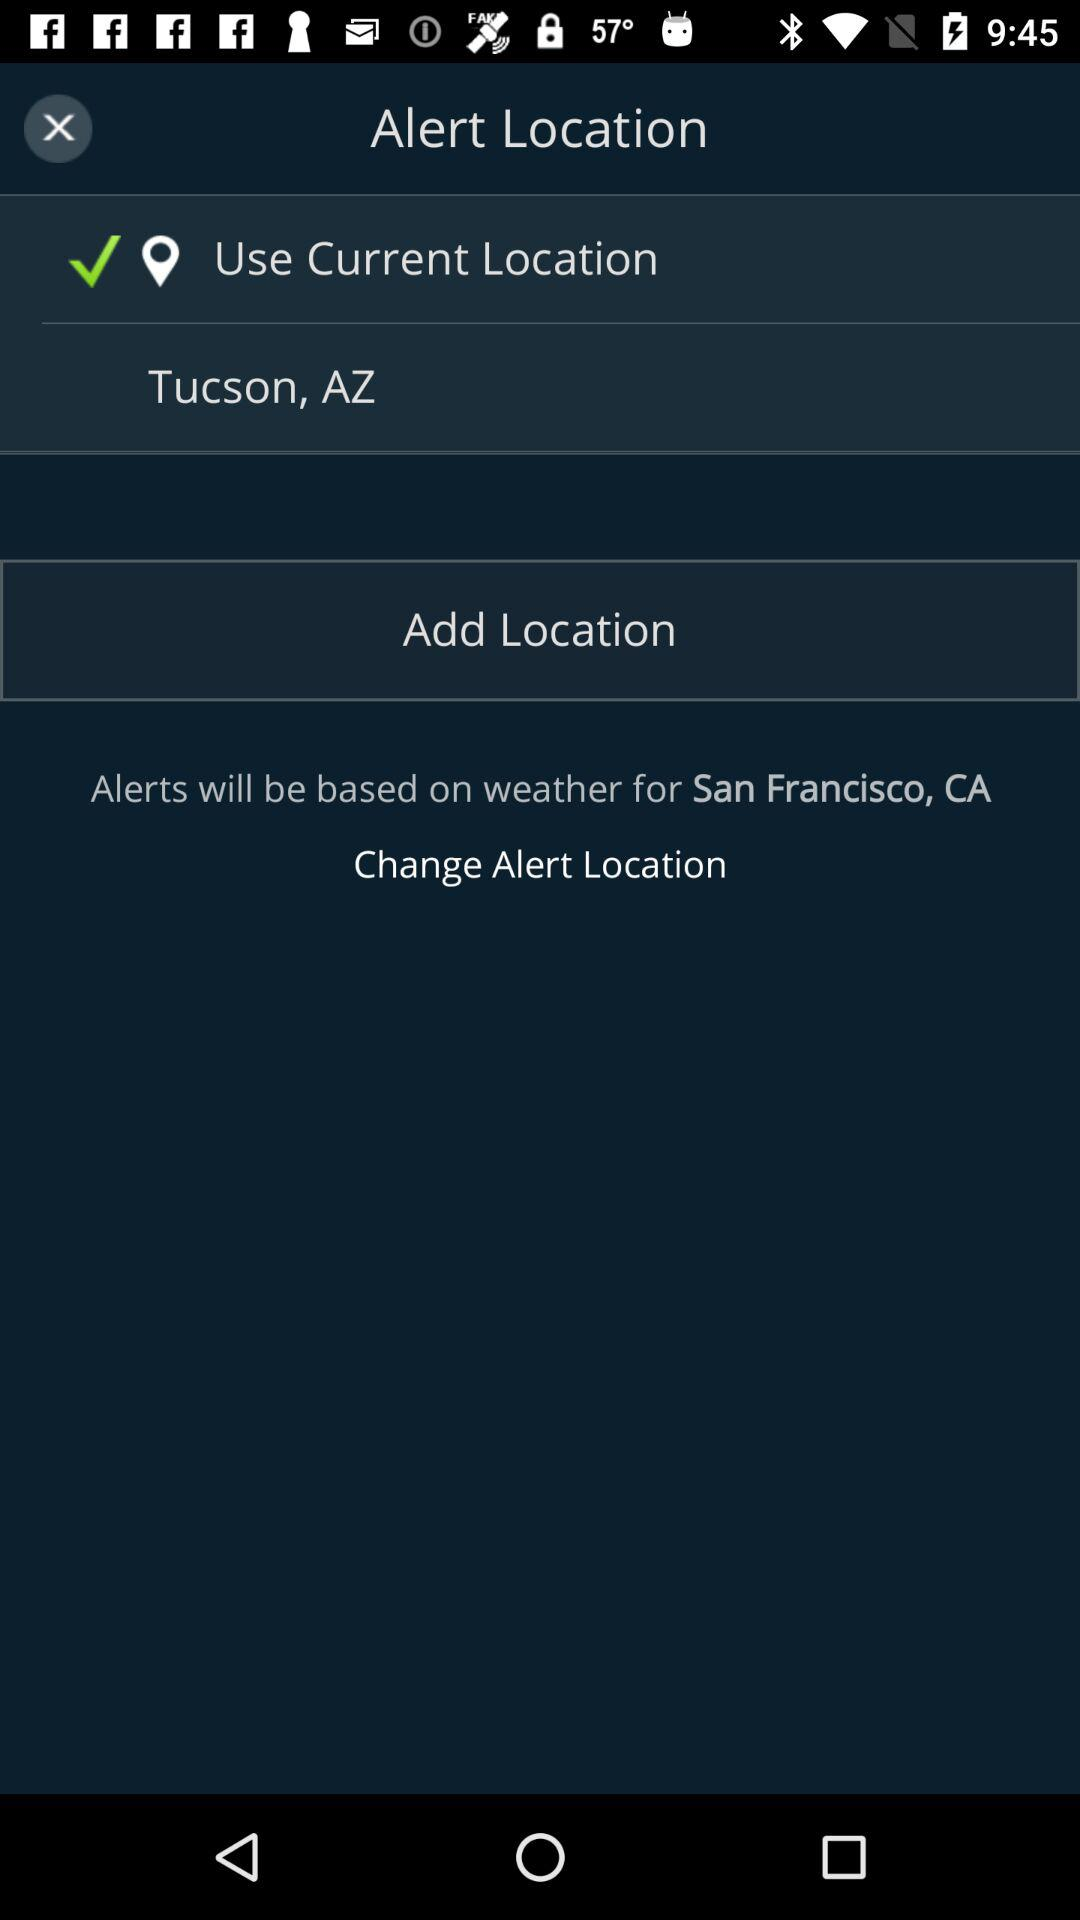What is the current location? The current location is Tucson, AZ. 